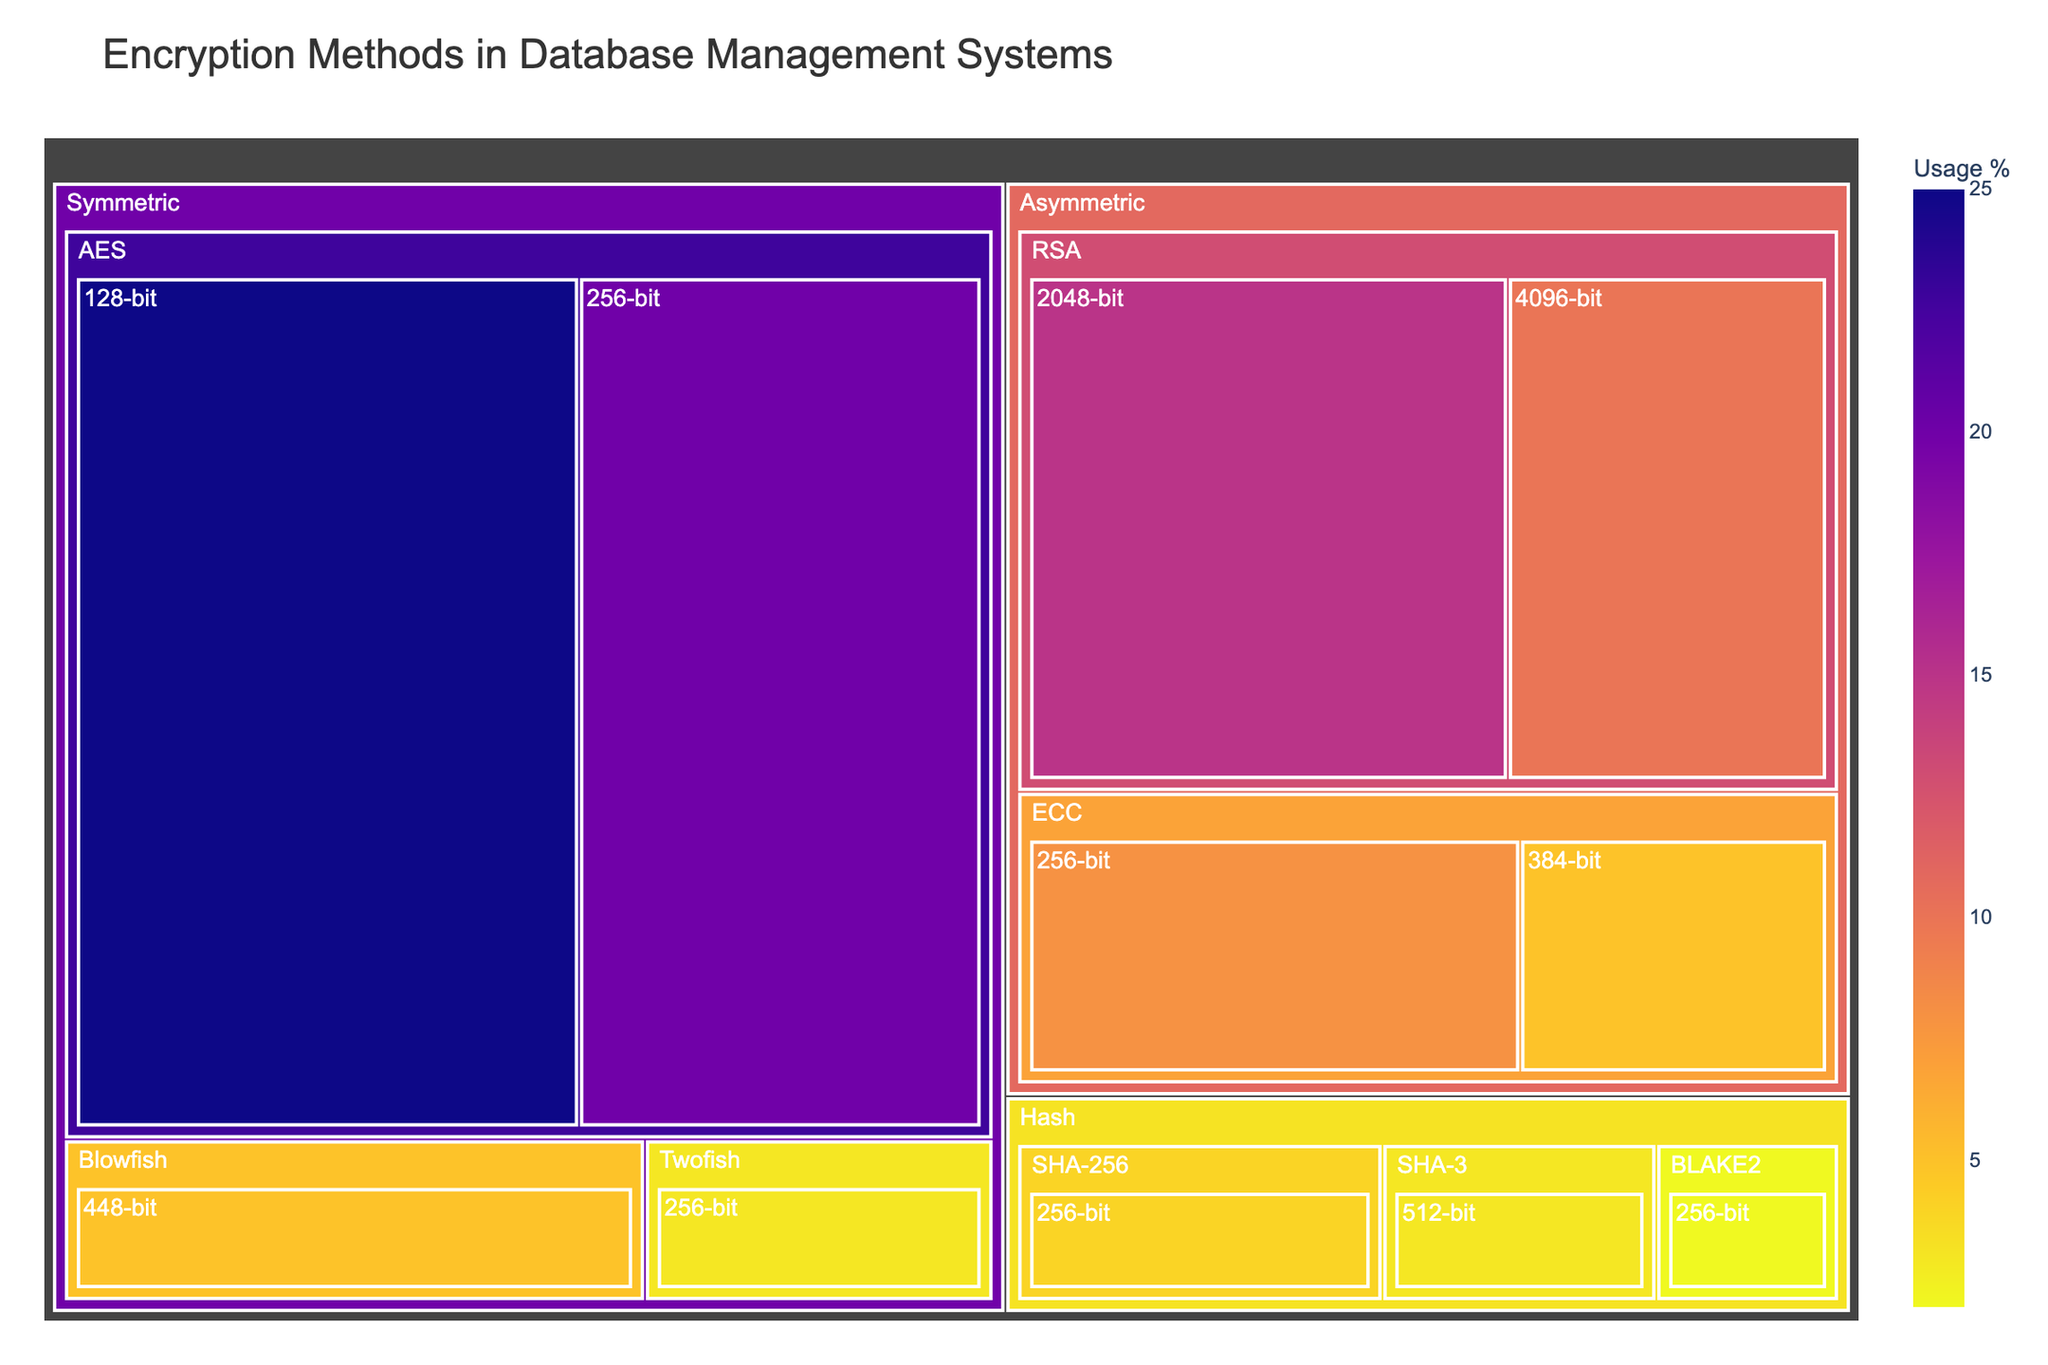What's the title of the treemap? The title of the treemap is placed prominently at the top and serves as an overview of the entire visualization context.
Answer: Encryption Methods in Database Management Systems What algorithm family has the highest overall usage percentage? By observing the largest blocks under the Algorithm Family section, the Symmetric family encompasses the largest combined area, indicating the highest usage percentage.
Answer: Symmetric Which specific encryption method under the Symmetric family has the highest usage percentage? Within the Symmetric section of the treemap, the largest block indicates the most widely used encryption method in that category.
Answer: AES 128-bit How does the usage percentage of RSA 2048-bit compare to AES 128-bit? Compare the size and the labeled usage percentages of these two specific sections. The RSA 2048-bit section is smaller and labeled with 15%, whereas the AES 128-bit section is 25%.
Answer: AES 128-bit is higher than RSA 2048-bit Summing up the usage percentages of all ECC methods, what's the total? Locate the ECC blocks, sum up their usage percentages: ECC 256-bit (8%) and ECC 384-bit (5%). The combined total usage is 8% + 5%.
Answer: 13% Which encryption method has the lowest usage percentage, and what is it? Look for the smallest block or segment within the entire treemap. The smallest labeled usage percentage will identify this method.
Answer: BLAKE2 256-bit How does SHA-256's usage compare to SHA-3's usage? Check both sections under the Hash category to compare their individual usage percentages. SHA-256 has a 4% usage while SHA-3 has 3%.
Answer: SHA-256 is higher than SHA-3 Among the encryption methods with key lengths of 256-bit, which one has the highest usage percentage? Look for all the 256-bit segments across different families and compare their usage percentages.
Answer: AES 256-bit What's the combined usage percentage of all asymmetric encryption methods? Sum the usage percentages of all methods under the Asymmetric category: RSA 2048-bit (15%), RSA 4096-bit (10%), ECC 256-bit (8%), and ECC 384-bit (5%). The combined total usage is 15% + 10% + 8% + 5%.
Answer: 38% Which algorithm family has the smallest representation in terms of distinct methods employed? Count the number of distinct methods under each algorithm family. The Hash family has three distinct methods.
Answer: Hash 